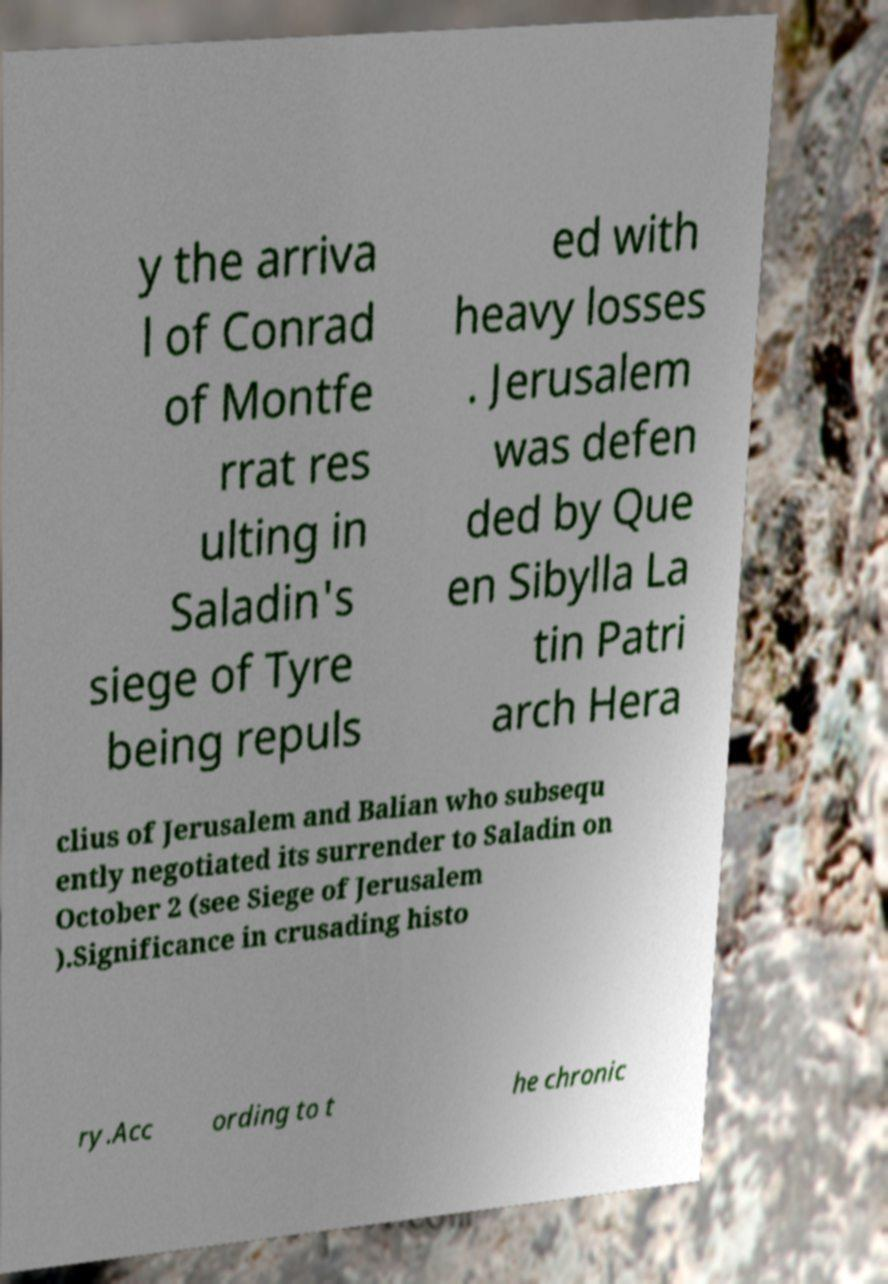Could you assist in decoding the text presented in this image and type it out clearly? y the arriva l of Conrad of Montfe rrat res ulting in Saladin's siege of Tyre being repuls ed with heavy losses . Jerusalem was defen ded by Que en Sibylla La tin Patri arch Hera clius of Jerusalem and Balian who subsequ ently negotiated its surrender to Saladin on October 2 (see Siege of Jerusalem ).Significance in crusading histo ry.Acc ording to t he chronic 